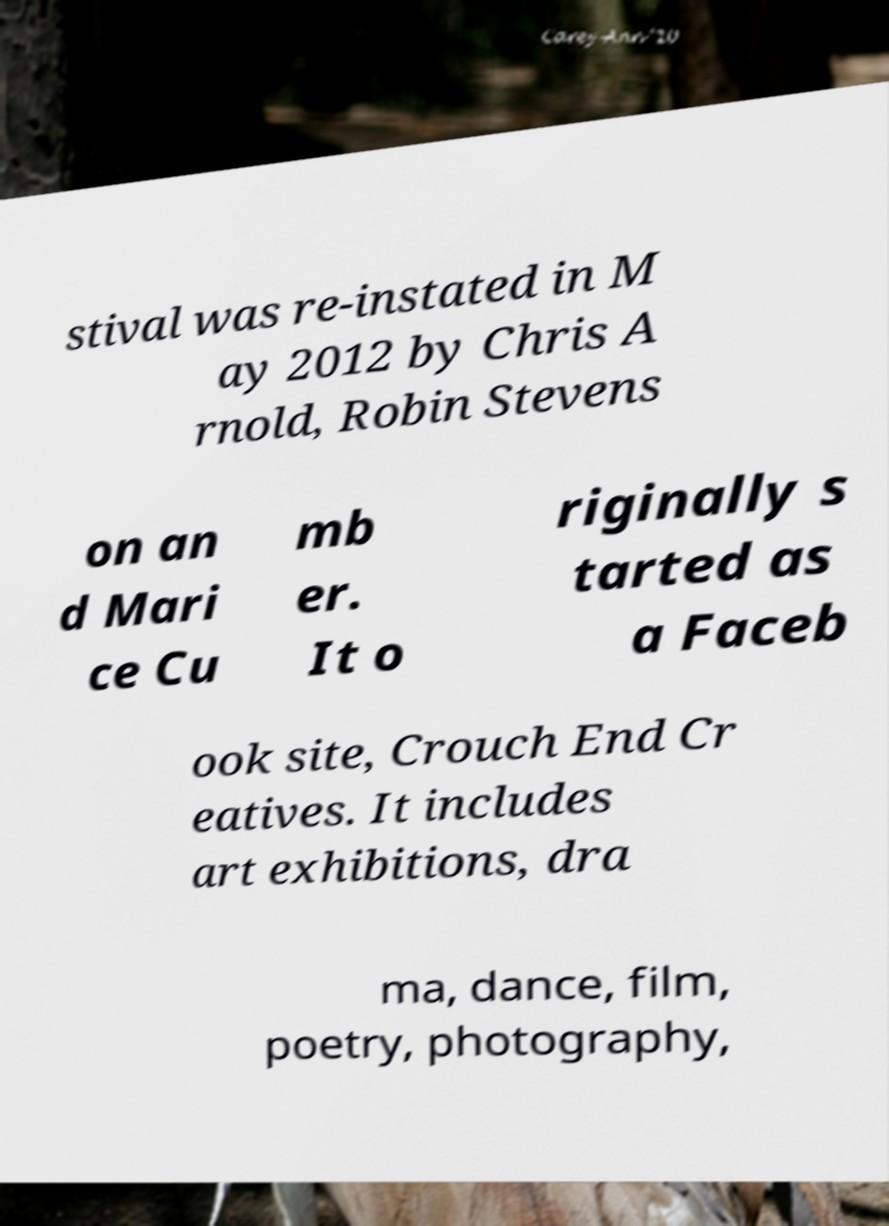For documentation purposes, I need the text within this image transcribed. Could you provide that? stival was re-instated in M ay 2012 by Chris A rnold, Robin Stevens on an d Mari ce Cu mb er. It o riginally s tarted as a Faceb ook site, Crouch End Cr eatives. It includes art exhibitions, dra ma, dance, film, poetry, photography, 